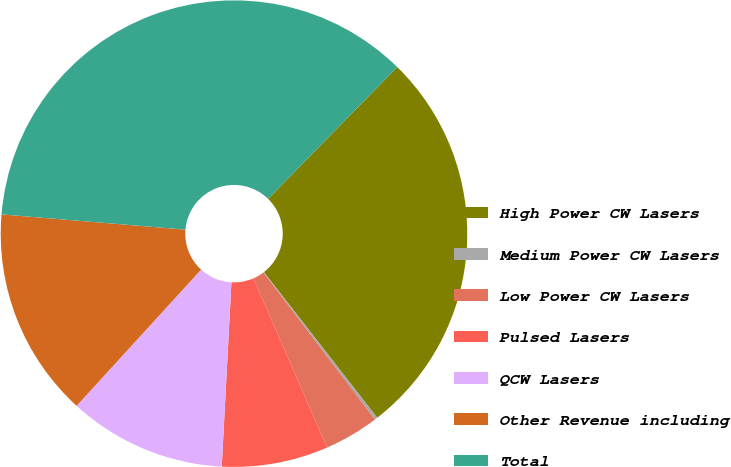Convert chart to OTSL. <chart><loc_0><loc_0><loc_500><loc_500><pie_chart><fcel>High Power CW Lasers<fcel>Medium Power CW Lasers<fcel>Low Power CW Lasers<fcel>Pulsed Lasers<fcel>QCW Lasers<fcel>Other Revenue including<fcel>Total<nl><fcel>27.14%<fcel>0.2%<fcel>3.79%<fcel>7.37%<fcel>10.95%<fcel>14.53%<fcel>36.02%<nl></chart> 